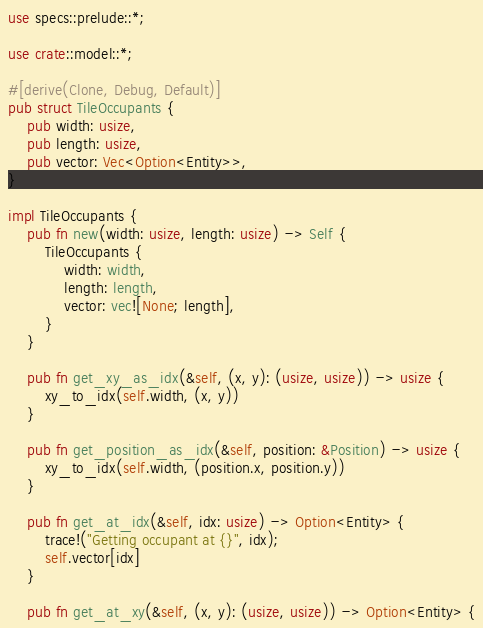Convert code to text. <code><loc_0><loc_0><loc_500><loc_500><_Rust_>use specs::prelude::*;

use crate::model::*;

#[derive(Clone, Debug, Default)]
pub struct TileOccupants {
    pub width: usize,
    pub length: usize,
    pub vector: Vec<Option<Entity>>,
}

impl TileOccupants {
    pub fn new(width: usize, length: usize) -> Self {
        TileOccupants {
            width: width,
            length: length,
            vector: vec![None; length],
        }
    }

    pub fn get_xy_as_idx(&self, (x, y): (usize, usize)) -> usize {
        xy_to_idx(self.width, (x, y))
    }

    pub fn get_position_as_idx(&self, position: &Position) -> usize {
        xy_to_idx(self.width, (position.x, position.y))
    }

    pub fn get_at_idx(&self, idx: usize) -> Option<Entity> {
        trace!("Getting occupant at {}", idx);
        self.vector[idx]
    }

    pub fn get_at_xy(&self, (x, y): (usize, usize)) -> Option<Entity> {</code> 